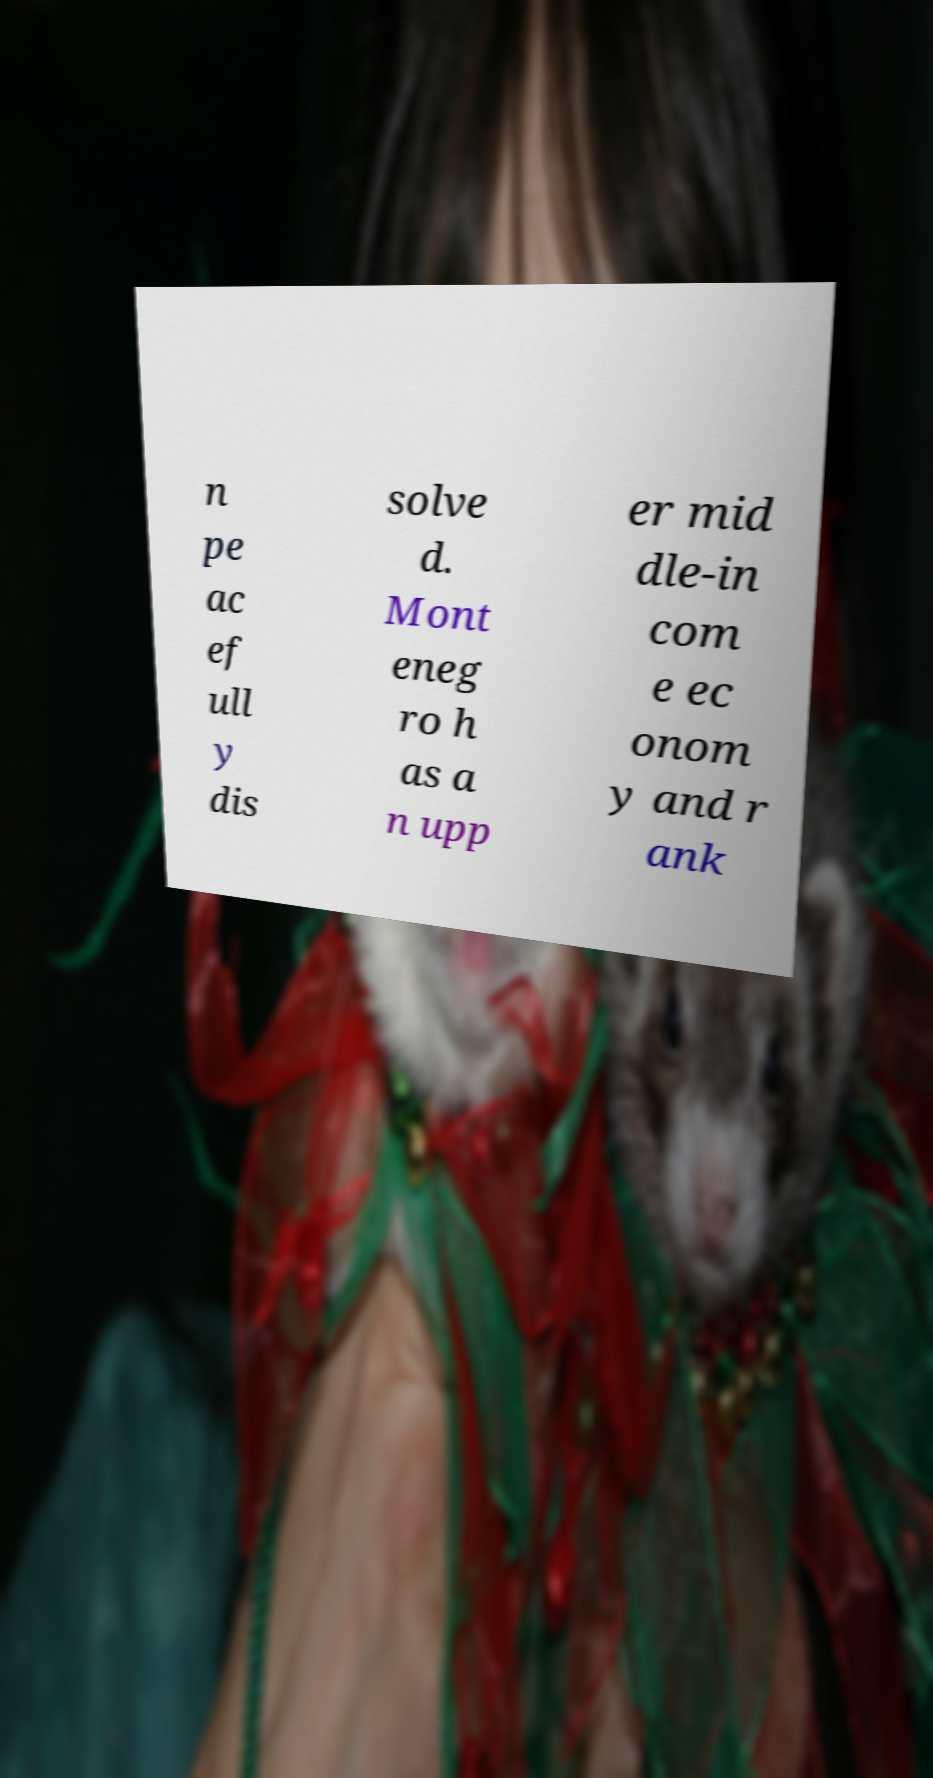There's text embedded in this image that I need extracted. Can you transcribe it verbatim? n pe ac ef ull y dis solve d. Mont eneg ro h as a n upp er mid dle-in com e ec onom y and r ank 